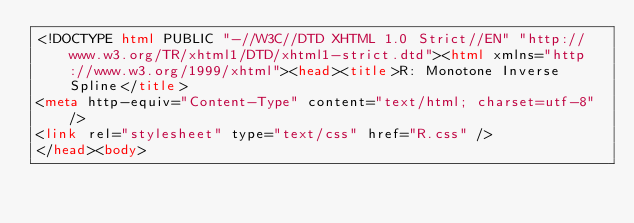<code> <loc_0><loc_0><loc_500><loc_500><_HTML_><!DOCTYPE html PUBLIC "-//W3C//DTD XHTML 1.0 Strict//EN" "http://www.w3.org/TR/xhtml1/DTD/xhtml1-strict.dtd"><html xmlns="http://www.w3.org/1999/xhtml"><head><title>R: Monotone Inverse Spline</title>
<meta http-equiv="Content-Type" content="text/html; charset=utf-8" />
<link rel="stylesheet" type="text/css" href="R.css" />
</head><body>
</code> 